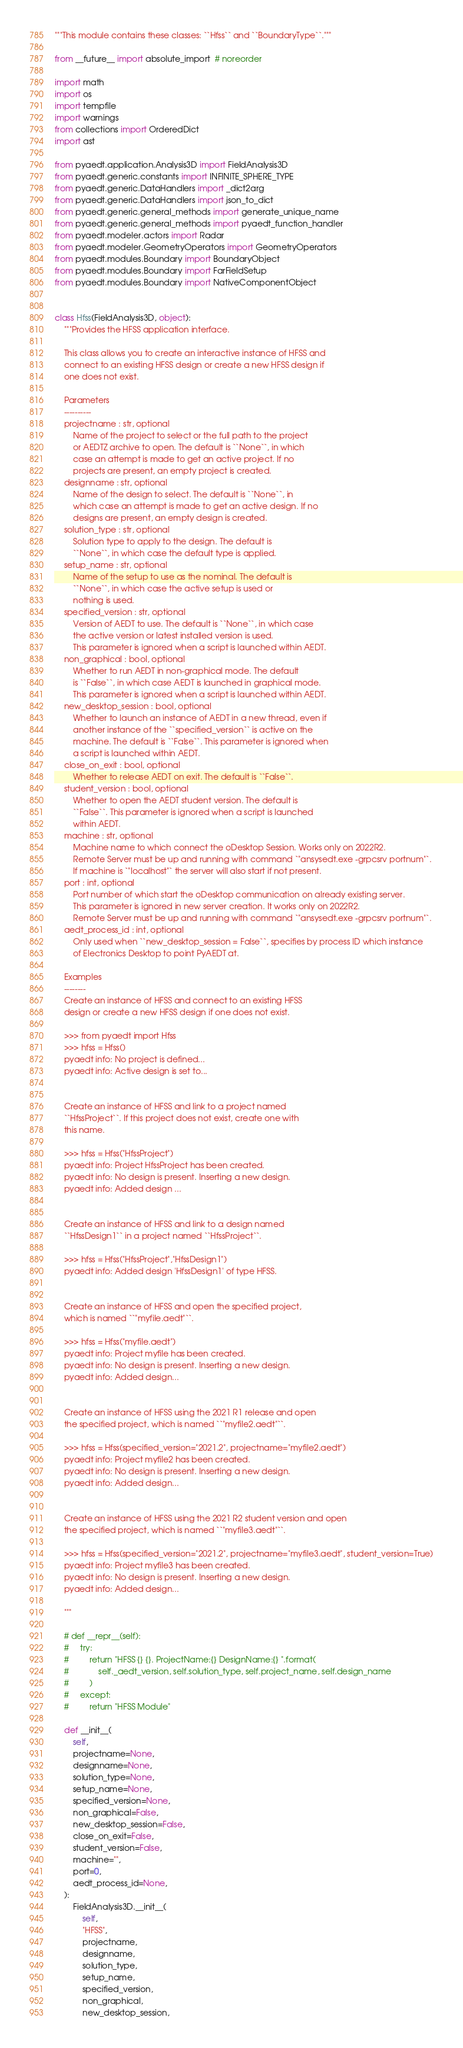<code> <loc_0><loc_0><loc_500><loc_500><_Python_>"""This module contains these classes: ``Hfss`` and ``BoundaryType``."""

from __future__ import absolute_import  # noreorder

import math
import os
import tempfile
import warnings
from collections import OrderedDict
import ast

from pyaedt.application.Analysis3D import FieldAnalysis3D
from pyaedt.generic.constants import INFINITE_SPHERE_TYPE
from pyaedt.generic.DataHandlers import _dict2arg
from pyaedt.generic.DataHandlers import json_to_dict
from pyaedt.generic.general_methods import generate_unique_name
from pyaedt.generic.general_methods import pyaedt_function_handler
from pyaedt.modeler.actors import Radar
from pyaedt.modeler.GeometryOperators import GeometryOperators
from pyaedt.modules.Boundary import BoundaryObject
from pyaedt.modules.Boundary import FarFieldSetup
from pyaedt.modules.Boundary import NativeComponentObject


class Hfss(FieldAnalysis3D, object):
    """Provides the HFSS application interface.

    This class allows you to create an interactive instance of HFSS and
    connect to an existing HFSS design or create a new HFSS design if
    one does not exist.

    Parameters
    ----------
    projectname : str, optional
        Name of the project to select or the full path to the project
        or AEDTZ archive to open. The default is ``None``, in which
        case an attempt is made to get an active project. If no
        projects are present, an empty project is created.
    designname : str, optional
        Name of the design to select. The default is ``None``, in
        which case an attempt is made to get an active design. If no
        designs are present, an empty design is created.
    solution_type : str, optional
        Solution type to apply to the design. The default is
        ``None``, in which case the default type is applied.
    setup_name : str, optional
        Name of the setup to use as the nominal. The default is
        ``None``, in which case the active setup is used or
        nothing is used.
    specified_version : str, optional
        Version of AEDT to use. The default is ``None``, in which case
        the active version or latest installed version is used.
        This parameter is ignored when a script is launched within AEDT.
    non_graphical : bool, optional
        Whether to run AEDT in non-graphical mode. The default
        is ``False``, in which case AEDT is launched in graphical mode.
        This parameter is ignored when a script is launched within AEDT.
    new_desktop_session : bool, optional
        Whether to launch an instance of AEDT in a new thread, even if
        another instance of the ``specified_version`` is active on the
        machine. The default is ``False``. This parameter is ignored when
        a script is launched within AEDT.
    close_on_exit : bool, optional
        Whether to release AEDT on exit. The default is ``False``.
    student_version : bool, optional
        Whether to open the AEDT student version. The default is
        ``False``. This parameter is ignored when a script is launched
        within AEDT.
    machine : str, optional
        Machine name to which connect the oDesktop Session. Works only on 2022R2.
        Remote Server must be up and running with command `"ansysedt.exe -grpcsrv portnum"`.
        If machine is `"localhost"` the server will also start if not present.
    port : int, optional
        Port number of which start the oDesktop communication on already existing server.
        This parameter is ignored in new server creation. It works only on 2022R2.
        Remote Server must be up and running with command `"ansysedt.exe -grpcsrv portnum"`.
    aedt_process_id : int, optional
        Only used when ``new_desktop_session = False``, specifies by process ID which instance
        of Electronics Desktop to point PyAEDT at.

    Examples
    --------
    Create an instance of HFSS and connect to an existing HFSS
    design or create a new HFSS design if one does not exist.

    >>> from pyaedt import Hfss
    >>> hfss = Hfss()
    pyaedt info: No project is defined...
    pyaedt info: Active design is set to...


    Create an instance of HFSS and link to a project named
    ``HfssProject``. If this project does not exist, create one with
    this name.

    >>> hfss = Hfss("HfssProject")
    pyaedt info: Project HfssProject has been created.
    pyaedt info: No design is present. Inserting a new design.
    pyaedt info: Added design ...


    Create an instance of HFSS and link to a design named
    ``HfssDesign1`` in a project named ``HfssProject``.

    >>> hfss = Hfss("HfssProject","HfssDesign1")
    pyaedt info: Added design 'HfssDesign1' of type HFSS.


    Create an instance of HFSS and open the specified project,
    which is named ``"myfile.aedt"``.

    >>> hfss = Hfss("myfile.aedt")
    pyaedt info: Project myfile has been created.
    pyaedt info: No design is present. Inserting a new design.
    pyaedt info: Added design...


    Create an instance of HFSS using the 2021 R1 release and open
    the specified project, which is named ``"myfile2.aedt"``.

    >>> hfss = Hfss(specified_version="2021.2", projectname="myfile2.aedt")
    pyaedt info: Project myfile2 has been created.
    pyaedt info: No design is present. Inserting a new design.
    pyaedt info: Added design...


    Create an instance of HFSS using the 2021 R2 student version and open
    the specified project, which is named ``"myfile3.aedt"``.

    >>> hfss = Hfss(specified_version="2021.2", projectname="myfile3.aedt", student_version=True)
    pyaedt info: Project myfile3 has been created.
    pyaedt info: No design is present. Inserting a new design.
    pyaedt info: Added design...

    """

    # def __repr__(self):
    #     try:
    #         return "HFSS {} {}. ProjectName:{} DesignName:{} ".format(
    #             self._aedt_version, self.solution_type, self.project_name, self.design_name
    #         )
    #     except:
    #         return "HFSS Module"

    def __init__(
        self,
        projectname=None,
        designname=None,
        solution_type=None,
        setup_name=None,
        specified_version=None,
        non_graphical=False,
        new_desktop_session=False,
        close_on_exit=False,
        student_version=False,
        machine="",
        port=0,
        aedt_process_id=None,
    ):
        FieldAnalysis3D.__init__(
            self,
            "HFSS",
            projectname,
            designname,
            solution_type,
            setup_name,
            specified_version,
            non_graphical,
            new_desktop_session,</code> 